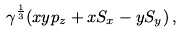<formula> <loc_0><loc_0><loc_500><loc_500>\gamma ^ { \frac { 1 } { 3 } } ( x y p _ { z } + x S _ { x } - y S _ { y } ) \, ,</formula> 